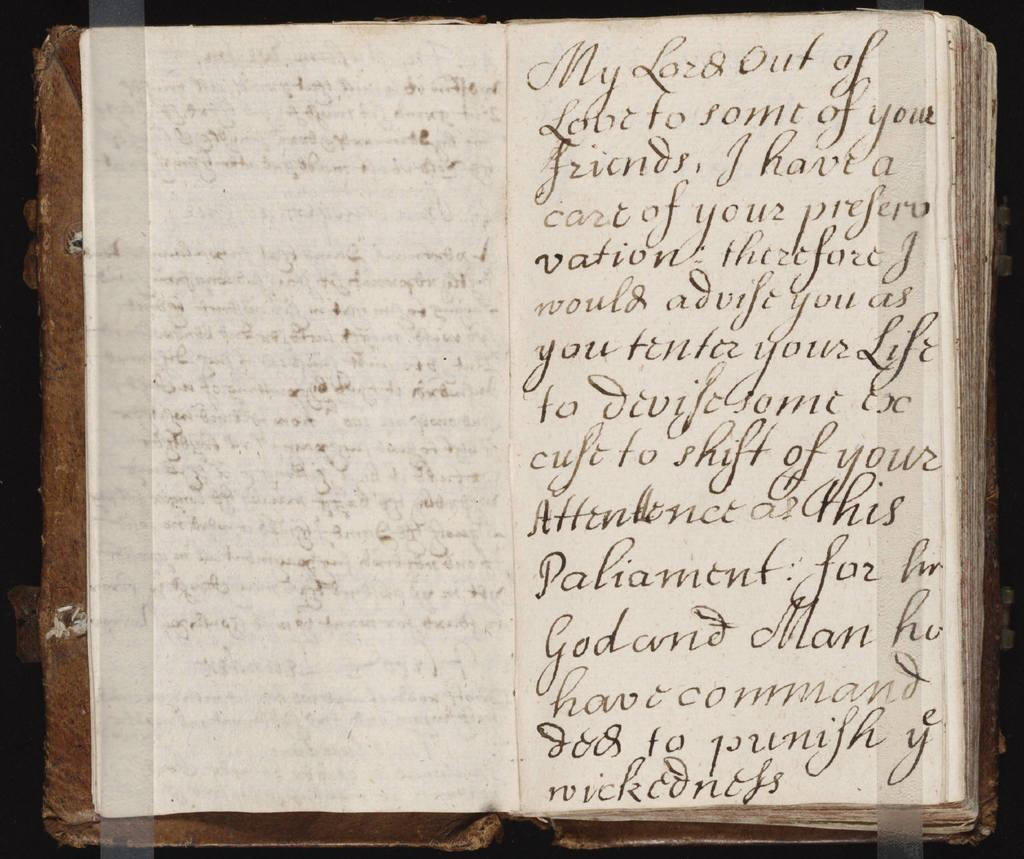Provide a one-sentence caption for the provided image. an open vintage book that is my lord out of love. 